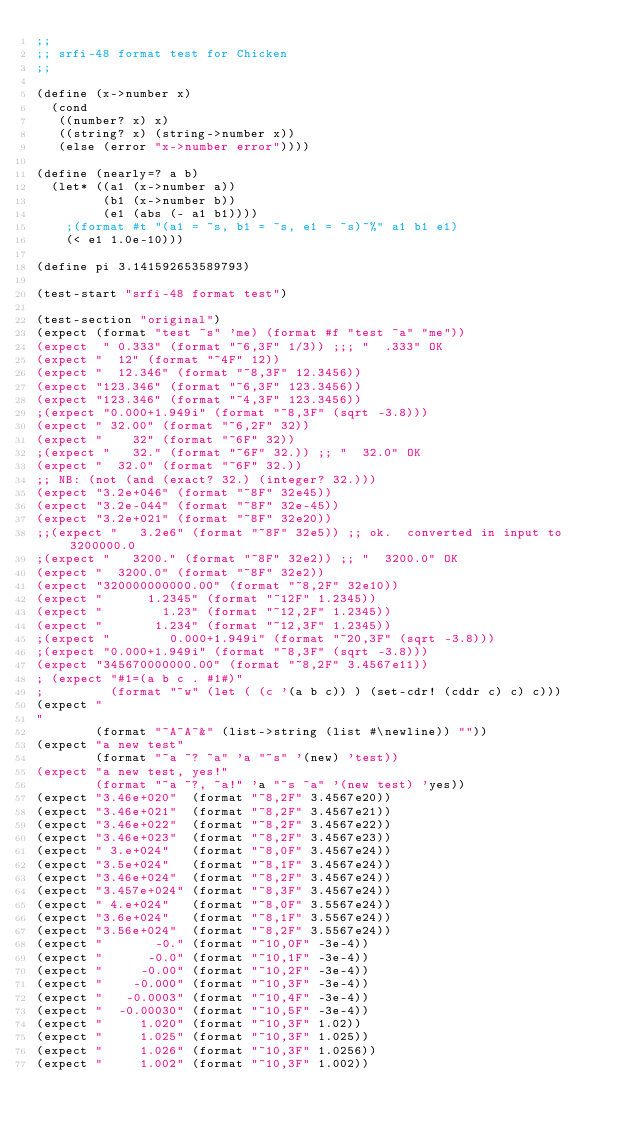Convert code to text. <code><loc_0><loc_0><loc_500><loc_500><_Scheme_>;;
;; srfi-48 format test for Chicken
;;

(define (x->number x)
  (cond
   ((number? x) x)
   ((string? x) (string->number x))
   (else (error "x->number error"))))

(define (nearly=? a b)
  (let* ((a1 (x->number a))
         (b1 (x->number b))
         (e1 (abs (- a1 b1))))
    ;(format #t "(a1 = ~s, b1 = ~s, e1 = ~s)~%" a1 b1 e1)
    (< e1 1.0e-10)))

(define pi 3.141592653589793)

(test-start "srfi-48 format test")

(test-section "original")
(expect (format "test ~s" 'me) (format #f "test ~a" "me"))
(expect  " 0.333" (format "~6,3F" 1/3)) ;;; "  .333" OK
(expect "  12" (format "~4F" 12))
(expect "  12.346" (format "~8,3F" 12.3456))
(expect "123.346" (format "~6,3F" 123.3456))
(expect "123.346" (format "~4,3F" 123.3456))
;(expect "0.000+1.949i" (format "~8,3F" (sqrt -3.8)))
(expect " 32.00" (format "~6,2F" 32))
(expect "    32" (format "~6F" 32))
;(expect "   32." (format "~6F" 32.)) ;; "  32.0" OK
(expect "  32.0" (format "~6F" 32.))
;; NB: (not (and (exact? 32.) (integer? 32.)))
(expect "3.2e+046" (format "~8F" 32e45))
(expect "3.2e-044" (format "~8F" 32e-45))
(expect "3.2e+021" (format "~8F" 32e20))
;;(expect "   3.2e6" (format "~8F" 32e5)) ;; ok.  converted in input to 3200000.0
;(expect "   3200." (format "~8F" 32e2)) ;; "  3200.0" OK
(expect "  3200.0" (format "~8F" 32e2))
(expect "320000000000.00" (format "~8,2F" 32e10))
(expect "      1.2345" (format "~12F" 1.2345))
(expect "        1.23" (format "~12,2F" 1.2345))
(expect "       1.234" (format "~12,3F" 1.2345))
;(expect "        0.000+1.949i" (format "~20,3F" (sqrt -3.8)))
;(expect "0.000+1.949i" (format "~8,3F" (sqrt -3.8)))
(expect "345670000000.00" (format "~8,2F" 3.4567e11))
; (expect "#1=(a b c . #1#)"
;         (format "~w" (let ( (c '(a b c)) ) (set-cdr! (cddr c) c) c)))
(expect "
"
        (format "~A~A~&" (list->string (list #\newline)) ""))
(expect "a new test"
        (format "~a ~? ~a" 'a "~s" '(new) 'test))
(expect "a new test, yes!"
        (format "~a ~?, ~a!" 'a "~s ~a" '(new test) 'yes))
(expect "3.46e+020"  (format "~8,2F" 3.4567e20))
(expect "3.46e+021"  (format "~8,2F" 3.4567e21))
(expect "3.46e+022"  (format "~8,2F" 3.4567e22))
(expect "3.46e+023"  (format "~8,2F" 3.4567e23))
(expect " 3.e+024"   (format "~8,0F" 3.4567e24))
(expect "3.5e+024"   (format "~8,1F" 3.4567e24))
(expect "3.46e+024"  (format "~8,2F" 3.4567e24))
(expect "3.457e+024" (format "~8,3F" 3.4567e24))
(expect " 4.e+024"   (format "~8,0F" 3.5567e24))
(expect "3.6e+024"   (format "~8,1F" 3.5567e24))
(expect "3.56e+024"  (format "~8,2F" 3.5567e24))
(expect "       -0." (format "~10,0F" -3e-4))
(expect "      -0.0" (format "~10,1F" -3e-4))
(expect "     -0.00" (format "~10,2F" -3e-4))
(expect "    -0.000" (format "~10,3F" -3e-4))
(expect "   -0.0003" (format "~10,4F" -3e-4))
(expect "  -0.00030" (format "~10,5F" -3e-4))
(expect "     1.020" (format "~10,3F" 1.02))
(expect "     1.025" (format "~10,3F" 1.025))
(expect "     1.026" (format "~10,3F" 1.0256))
(expect "     1.002" (format "~10,3F" 1.002))</code> 